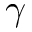Convert formula to latex. <formula><loc_0><loc_0><loc_500><loc_500>\gamma</formula> 